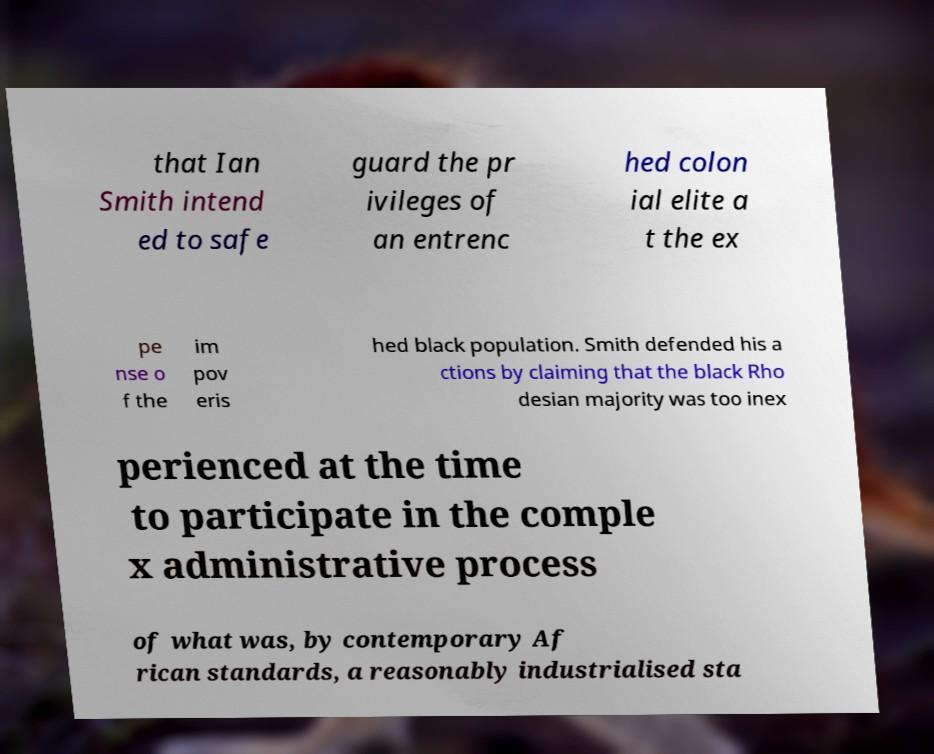What messages or text are displayed in this image? I need them in a readable, typed format. that Ian Smith intend ed to safe guard the pr ivileges of an entrenc hed colon ial elite a t the ex pe nse o f the im pov eris hed black population. Smith defended his a ctions by claiming that the black Rho desian majority was too inex perienced at the time to participate in the comple x administrative process of what was, by contemporary Af rican standards, a reasonably industrialised sta 